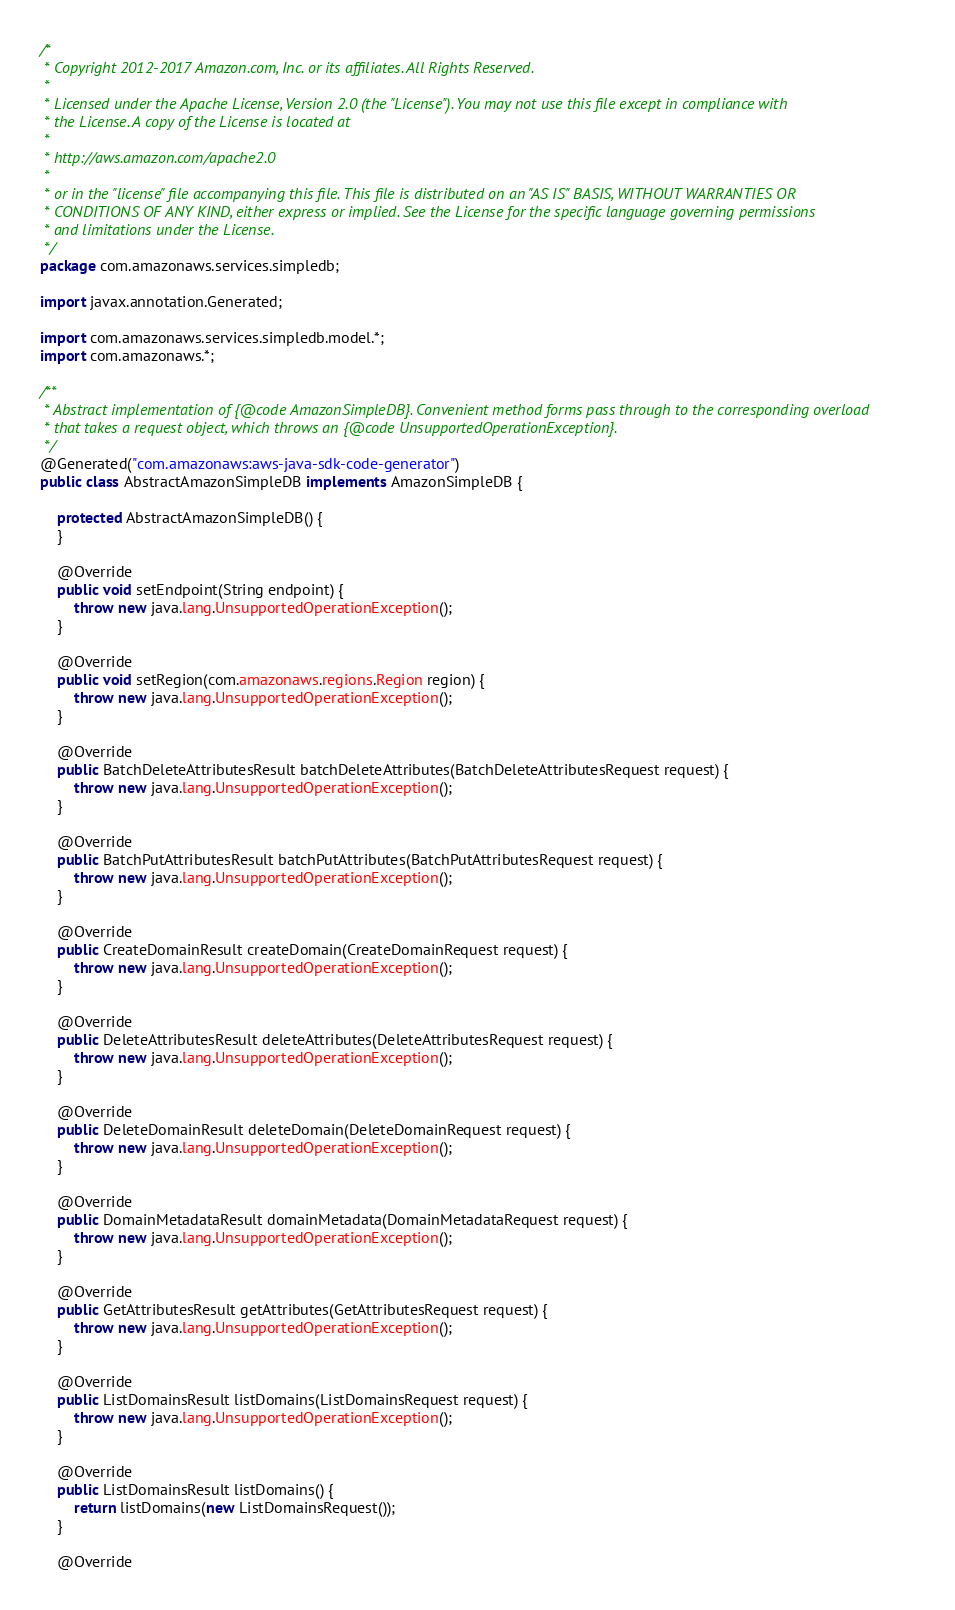<code> <loc_0><loc_0><loc_500><loc_500><_Java_>/*
 * Copyright 2012-2017 Amazon.com, Inc. or its affiliates. All Rights Reserved.
 * 
 * Licensed under the Apache License, Version 2.0 (the "License"). You may not use this file except in compliance with
 * the License. A copy of the License is located at
 * 
 * http://aws.amazon.com/apache2.0
 * 
 * or in the "license" file accompanying this file. This file is distributed on an "AS IS" BASIS, WITHOUT WARRANTIES OR
 * CONDITIONS OF ANY KIND, either express or implied. See the License for the specific language governing permissions
 * and limitations under the License.
 */
package com.amazonaws.services.simpledb;

import javax.annotation.Generated;

import com.amazonaws.services.simpledb.model.*;
import com.amazonaws.*;

/**
 * Abstract implementation of {@code AmazonSimpleDB}. Convenient method forms pass through to the corresponding overload
 * that takes a request object, which throws an {@code UnsupportedOperationException}.
 */
@Generated("com.amazonaws:aws-java-sdk-code-generator")
public class AbstractAmazonSimpleDB implements AmazonSimpleDB {

    protected AbstractAmazonSimpleDB() {
    }

    @Override
    public void setEndpoint(String endpoint) {
        throw new java.lang.UnsupportedOperationException();
    }

    @Override
    public void setRegion(com.amazonaws.regions.Region region) {
        throw new java.lang.UnsupportedOperationException();
    }

    @Override
    public BatchDeleteAttributesResult batchDeleteAttributes(BatchDeleteAttributesRequest request) {
        throw new java.lang.UnsupportedOperationException();
    }

    @Override
    public BatchPutAttributesResult batchPutAttributes(BatchPutAttributesRequest request) {
        throw new java.lang.UnsupportedOperationException();
    }

    @Override
    public CreateDomainResult createDomain(CreateDomainRequest request) {
        throw new java.lang.UnsupportedOperationException();
    }

    @Override
    public DeleteAttributesResult deleteAttributes(DeleteAttributesRequest request) {
        throw new java.lang.UnsupportedOperationException();
    }

    @Override
    public DeleteDomainResult deleteDomain(DeleteDomainRequest request) {
        throw new java.lang.UnsupportedOperationException();
    }

    @Override
    public DomainMetadataResult domainMetadata(DomainMetadataRequest request) {
        throw new java.lang.UnsupportedOperationException();
    }

    @Override
    public GetAttributesResult getAttributes(GetAttributesRequest request) {
        throw new java.lang.UnsupportedOperationException();
    }

    @Override
    public ListDomainsResult listDomains(ListDomainsRequest request) {
        throw new java.lang.UnsupportedOperationException();
    }

    @Override
    public ListDomainsResult listDomains() {
        return listDomains(new ListDomainsRequest());
    }

    @Override</code> 